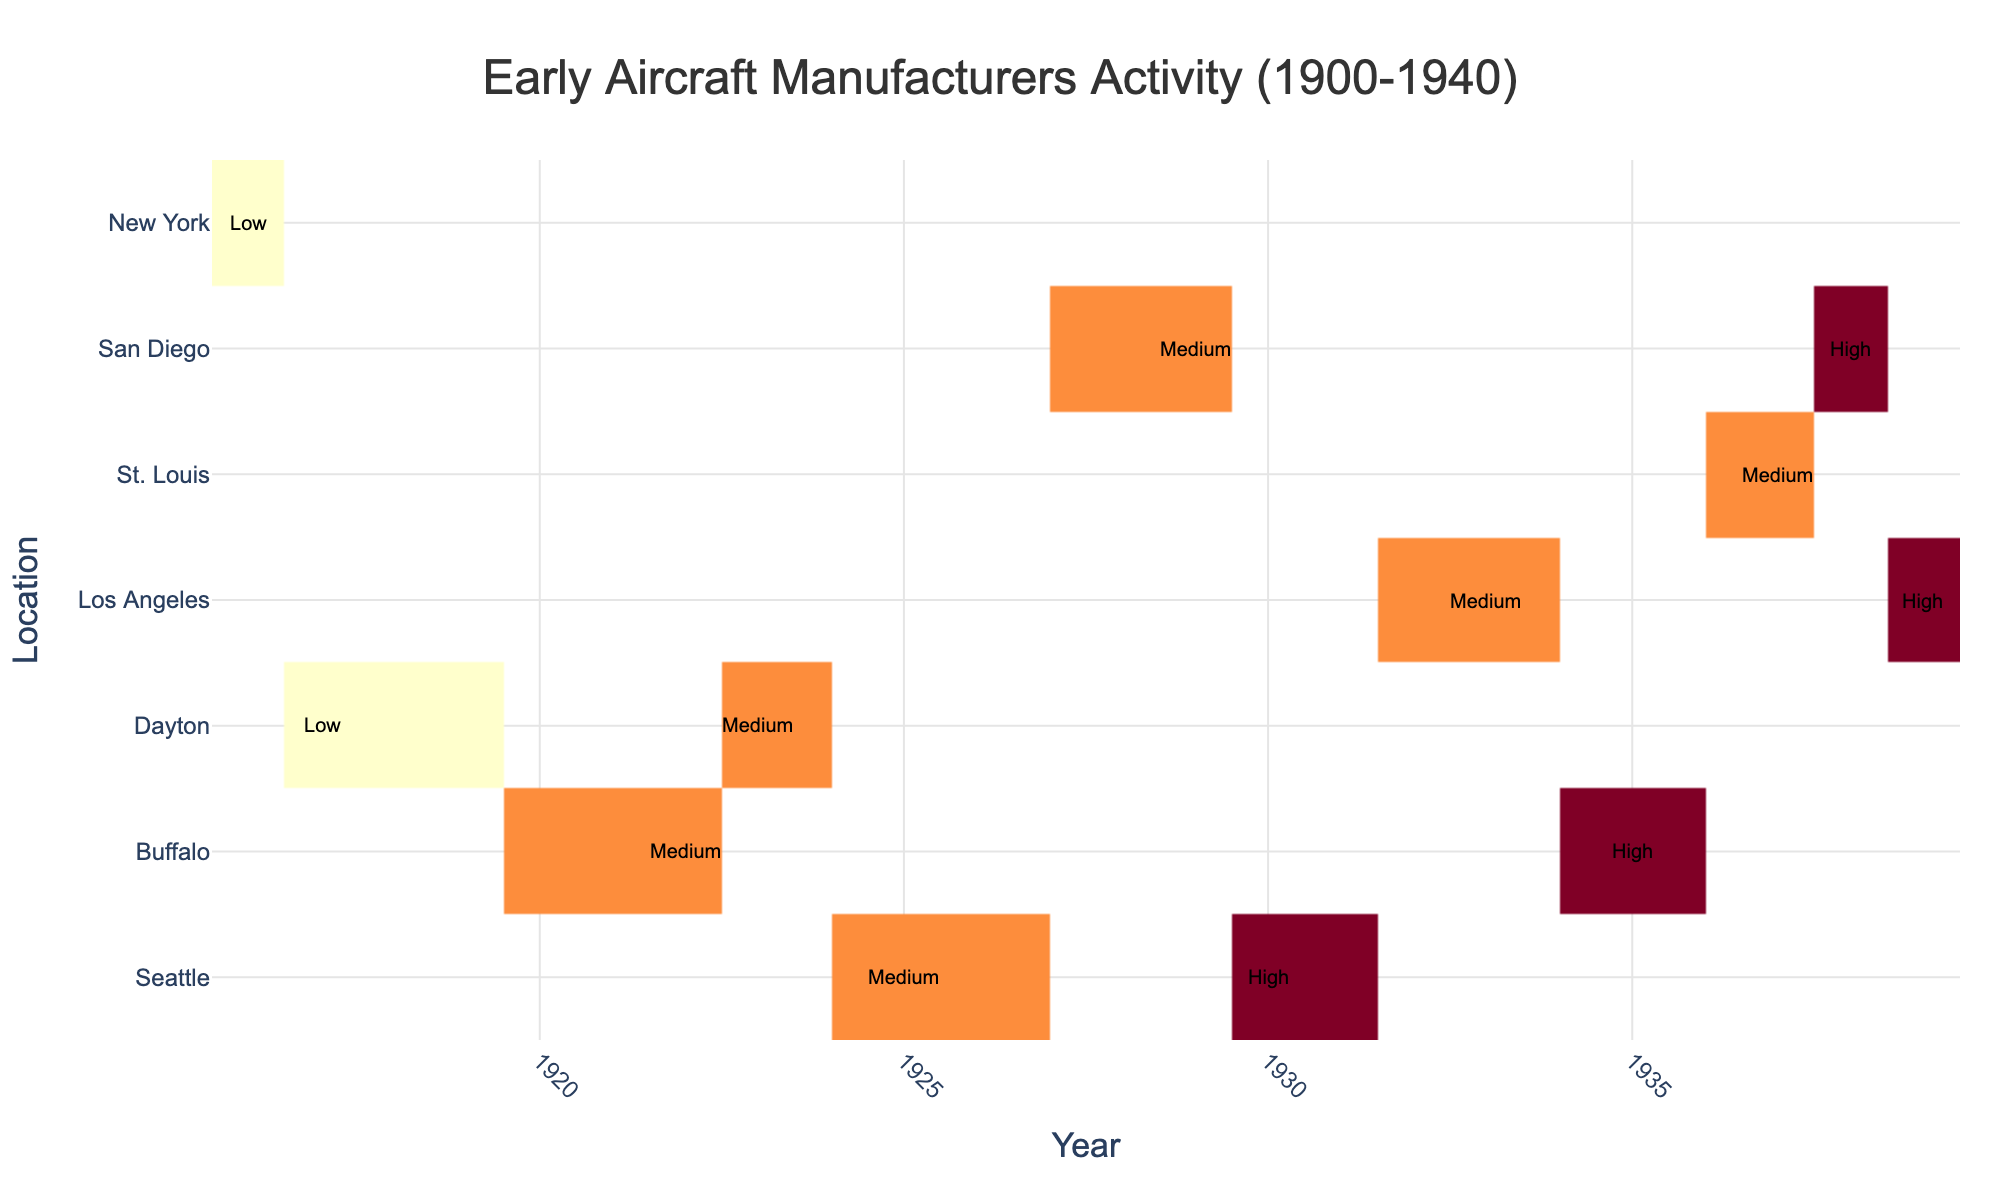What is the title of the heatmap? The title is usually found at the top of the figure and summarizes what the heatmap represents. In this case, it should be related to the activities of aircraft manufacturers between 1900 and 1940.
Answer: Early Aircraft Manufacturers Activity (1900-1940) Which location has the highest activity level in 1939? To find the location with the highest activity level in 1939, look at the column for the year 1939 and identify which row has the highest activity level annotated.
Answer: Los Angeles What is the trend of Boeing's activity levels from 1925 to 1930? First, locate Boeing’s data points from 1925 and 1930, and note their activity levels. Then, observe the changes in these levels over the years.
Answer: Medium to High Compare the employment numbers between Lockheed in 1933 and 1939. Which year had higher employment? Locate the rows for Lockheed in 1933 and 1939 and compare the employment numbers mentioned in the hover text (or annotation, if applicable).
Answer: 1939 What year did Curtiss-Wright have a high activity level in Buffalo? Locate Curtiss-Wright in Buffalo on the heatmap and identify the year when the activity level is marked as high.
Answer: 1935 Where was Wright-Martin's workshop located in 1917, and what was the activity level? Find Wright-Martin in the year 1917 and identify the location and the annotated activity level for that data point.
Answer: Dayton, Low Sum the production quantities for Consolidated Aircraft in 1929 and 1938. What is the total? Locate the production quantities for Consolidated Aircraft in 1929 and 1938. Add these quantities together to find the total. 25 + 87 = 112
Answer: 112 Which manufacturer had the highest employment in Buffalo, and what was the employment number? Look for the data points in Buffalo and compare the employment numbers to find the highest one; then identify the corresponding manufacturer.
Answer: Curtiss-Wright, 3700 How does the activity level of J.G. White in 1916 compare with Wright-Martin in 1917? Find the activity levels for J.G. White in 1916 and Wright-Martin in 1917, then compare the two.
Answer: J.G. White (Low) is equal to Wright-Martin (Low) Identify the activity level for Ryan in St. Louis in 1937, and indicate the employment and production for that year. Locate the data point for Ryan in St. Louis in 1937, note the annotated activity level, and check the employment and production numbers from the hover text.
Answer: Medium, Employment: 3100, Production: 45 